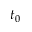<formula> <loc_0><loc_0><loc_500><loc_500>t _ { 0 }</formula> 